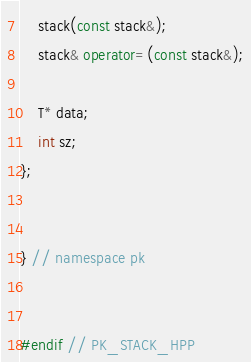Convert code to text. <code><loc_0><loc_0><loc_500><loc_500><_C++_>    stack(const stack&);
    stack& operator=(const stack&);

    T* data;
    int sz;
};


} // namespace pk


#endif // PK_STACK_HPP
</code> 